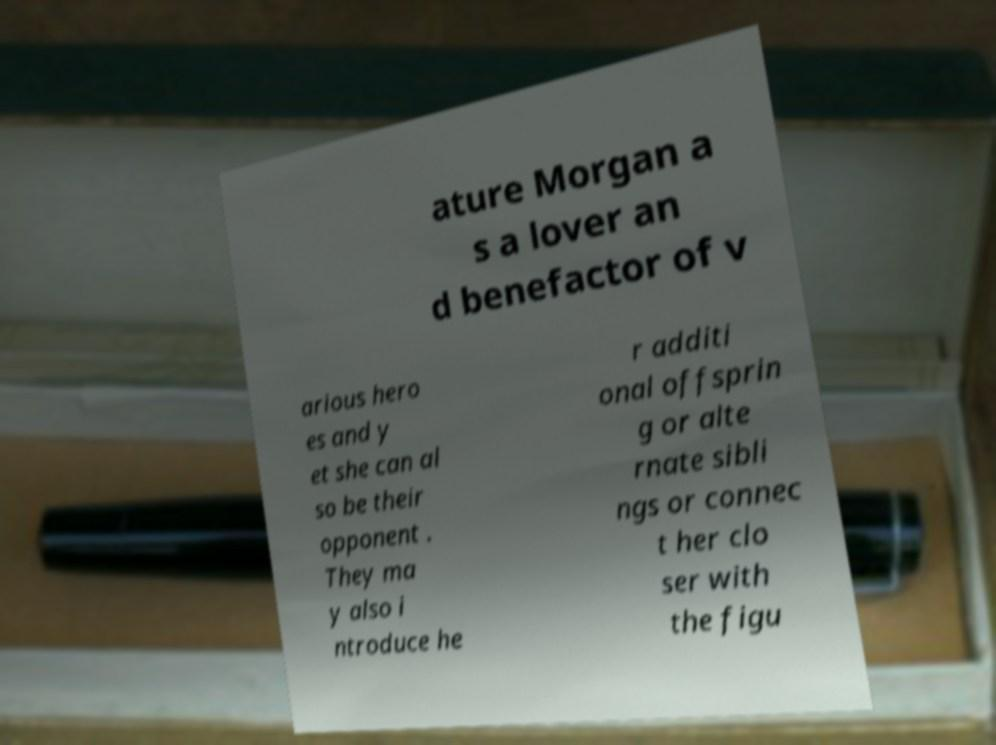Could you assist in decoding the text presented in this image and type it out clearly? ature Morgan a s a lover an d benefactor of v arious hero es and y et she can al so be their opponent . They ma y also i ntroduce he r additi onal offsprin g or alte rnate sibli ngs or connec t her clo ser with the figu 